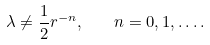<formula> <loc_0><loc_0><loc_500><loc_500>\lambda \neq \frac { 1 } { 2 } r ^ { - n } , \quad n = 0 , 1 , \dots .</formula> 